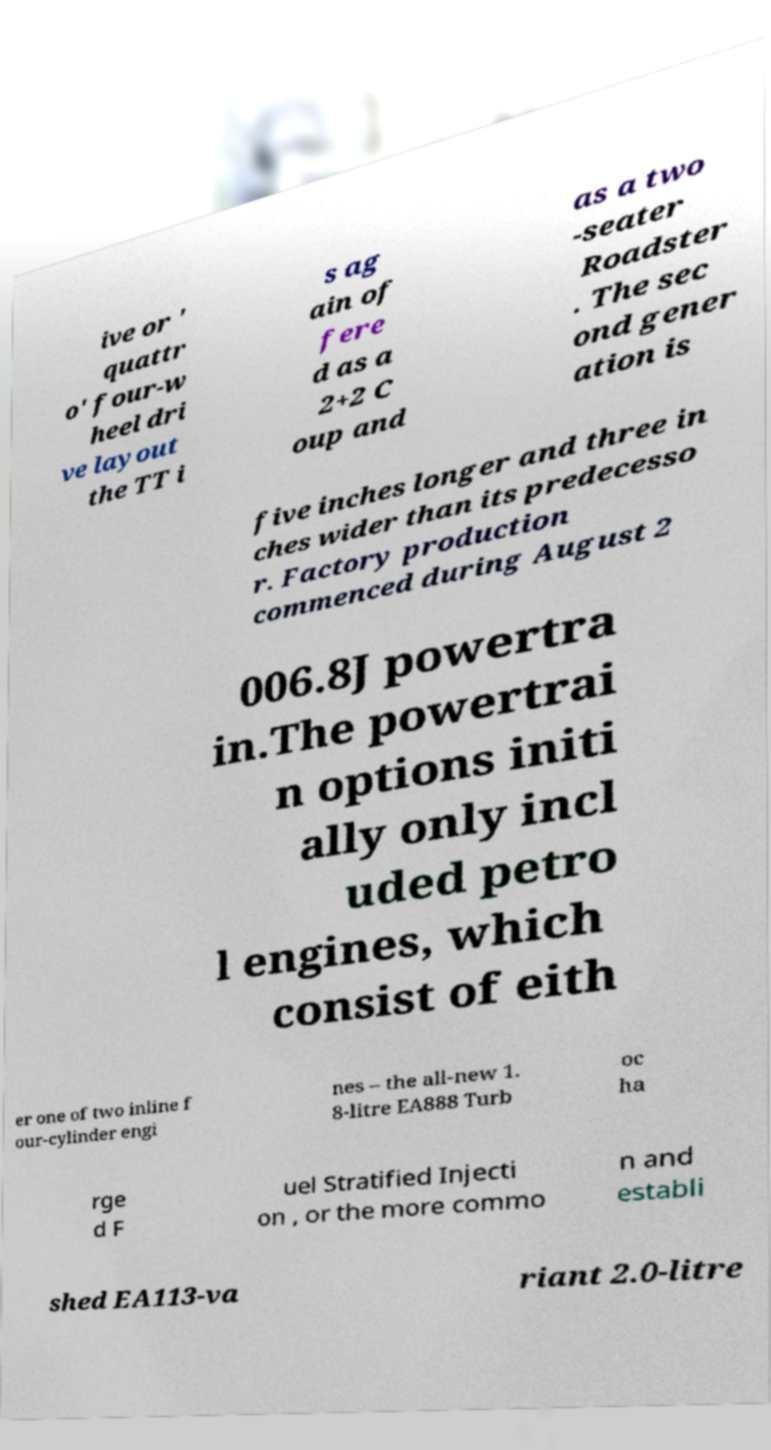Could you extract and type out the text from this image? ive or ' quattr o' four-w heel dri ve layout the TT i s ag ain of fere d as a 2+2 C oup and as a two -seater Roadster . The sec ond gener ation is five inches longer and three in ches wider than its predecesso r. Factory production commenced during August 2 006.8J powertra in.The powertrai n options initi ally only incl uded petro l engines, which consist of eith er one of two inline f our-cylinder engi nes – the all-new 1. 8-litre EA888 Turb oc ha rge d F uel Stratified Injecti on , or the more commo n and establi shed EA113-va riant 2.0-litre 